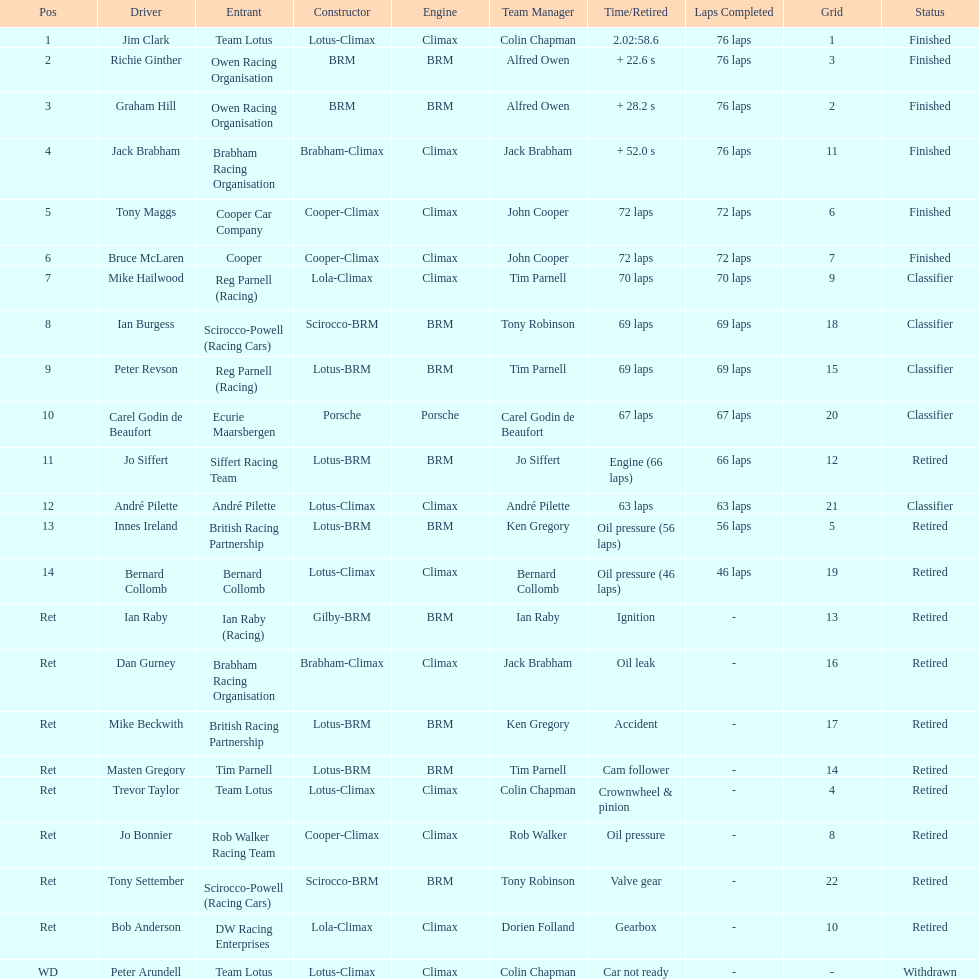How many different drivers are listed? 23. 